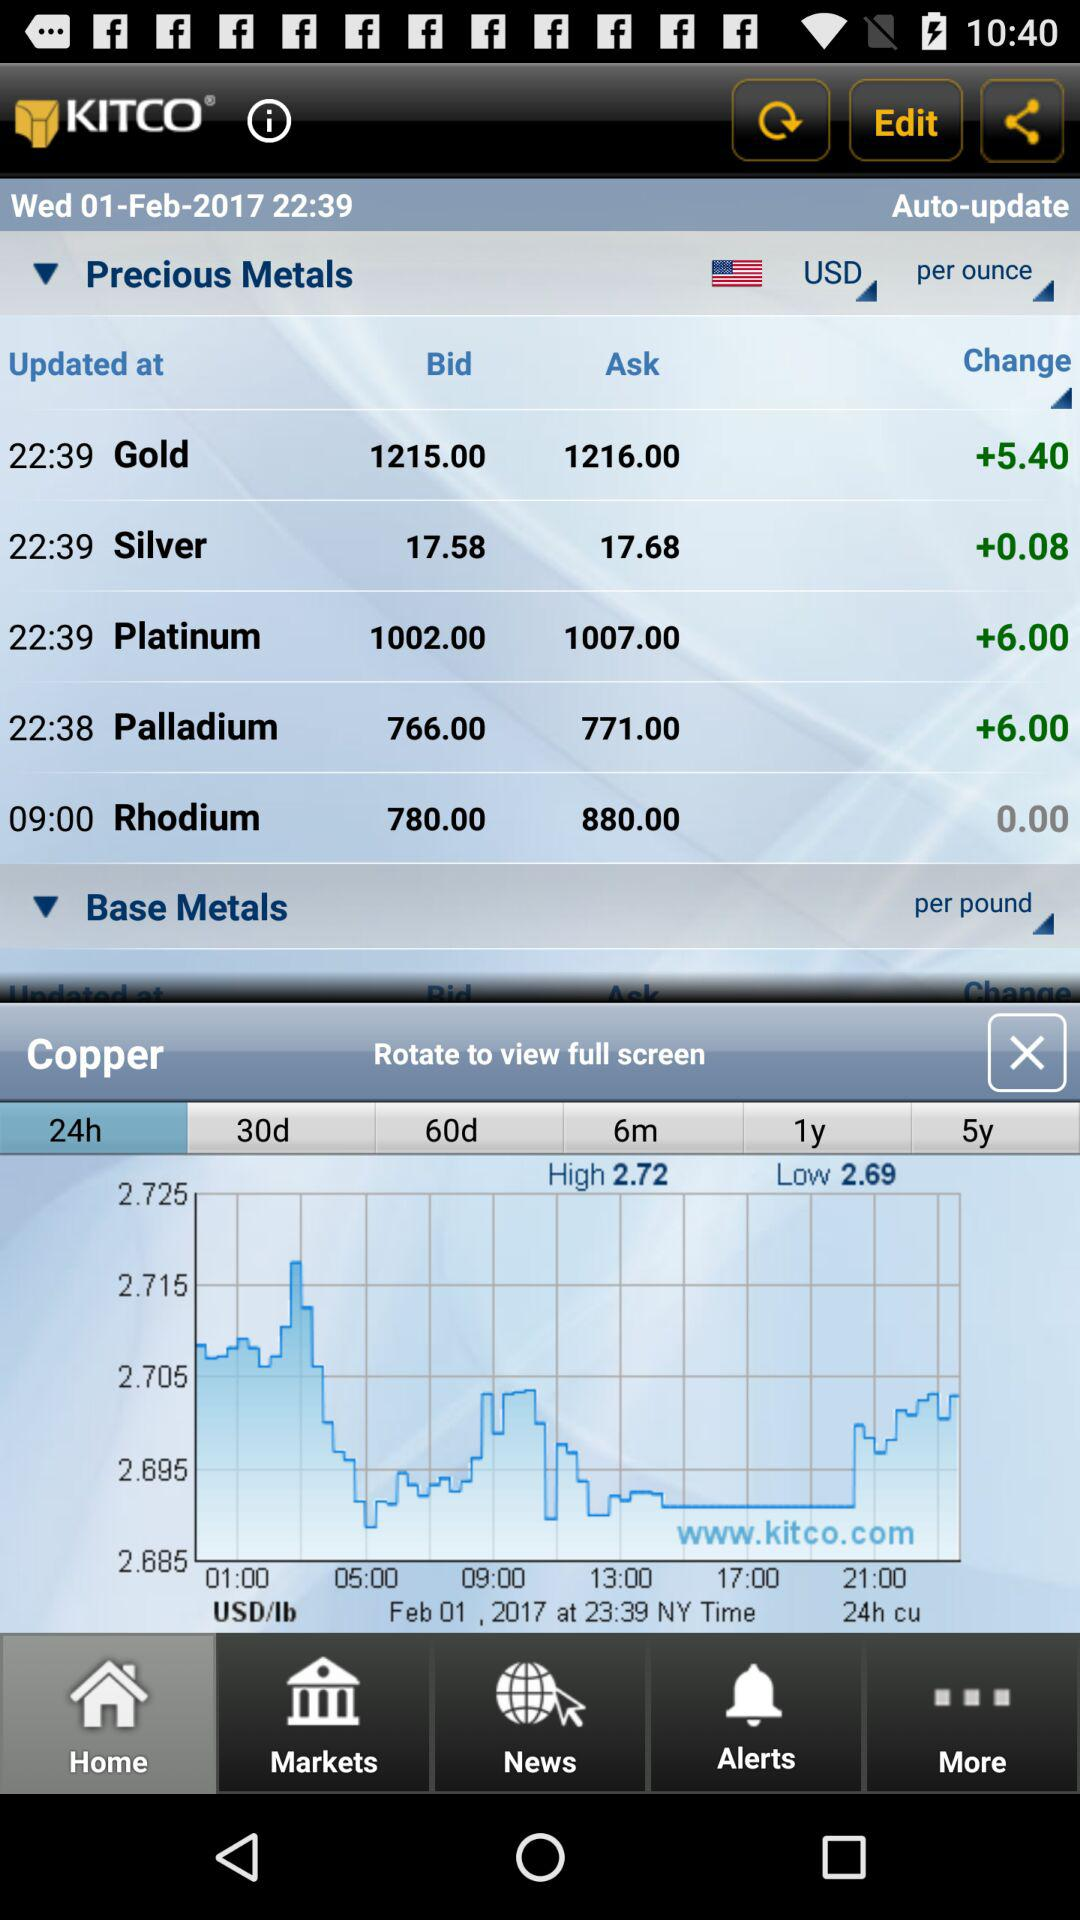Which country is selected? The selected country is the United States of America. 